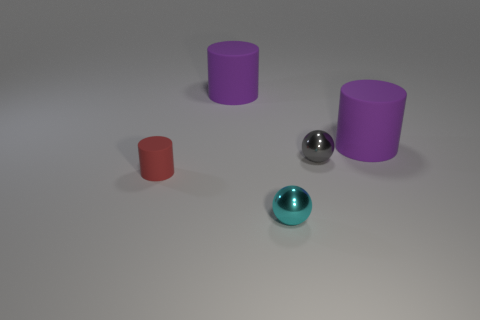Is the number of cyan things that are behind the red thing less than the number of small gray metal balls that are on the right side of the gray thing?
Offer a very short reply. No. What is the shape of the thing that is both behind the tiny gray ball and on the left side of the cyan shiny object?
Offer a terse response. Cylinder. What number of purple objects are the same shape as the small gray metallic object?
Keep it short and to the point. 0. The cyan thing that is the same material as the tiny gray sphere is what size?
Make the answer very short. Small. Is the number of purple objects greater than the number of small gray metal cubes?
Provide a short and direct response. Yes. What is the color of the shiny sphere that is in front of the red cylinder?
Offer a terse response. Cyan. There is a matte object that is both to the left of the gray object and on the right side of the small cylinder; what size is it?
Keep it short and to the point. Large. How many blue cubes have the same size as the gray metal object?
Your answer should be very brief. 0. There is a small gray thing that is the same shape as the tiny cyan thing; what is it made of?
Ensure brevity in your answer.  Metal. Is the shape of the red rubber thing the same as the cyan object?
Ensure brevity in your answer.  No. 